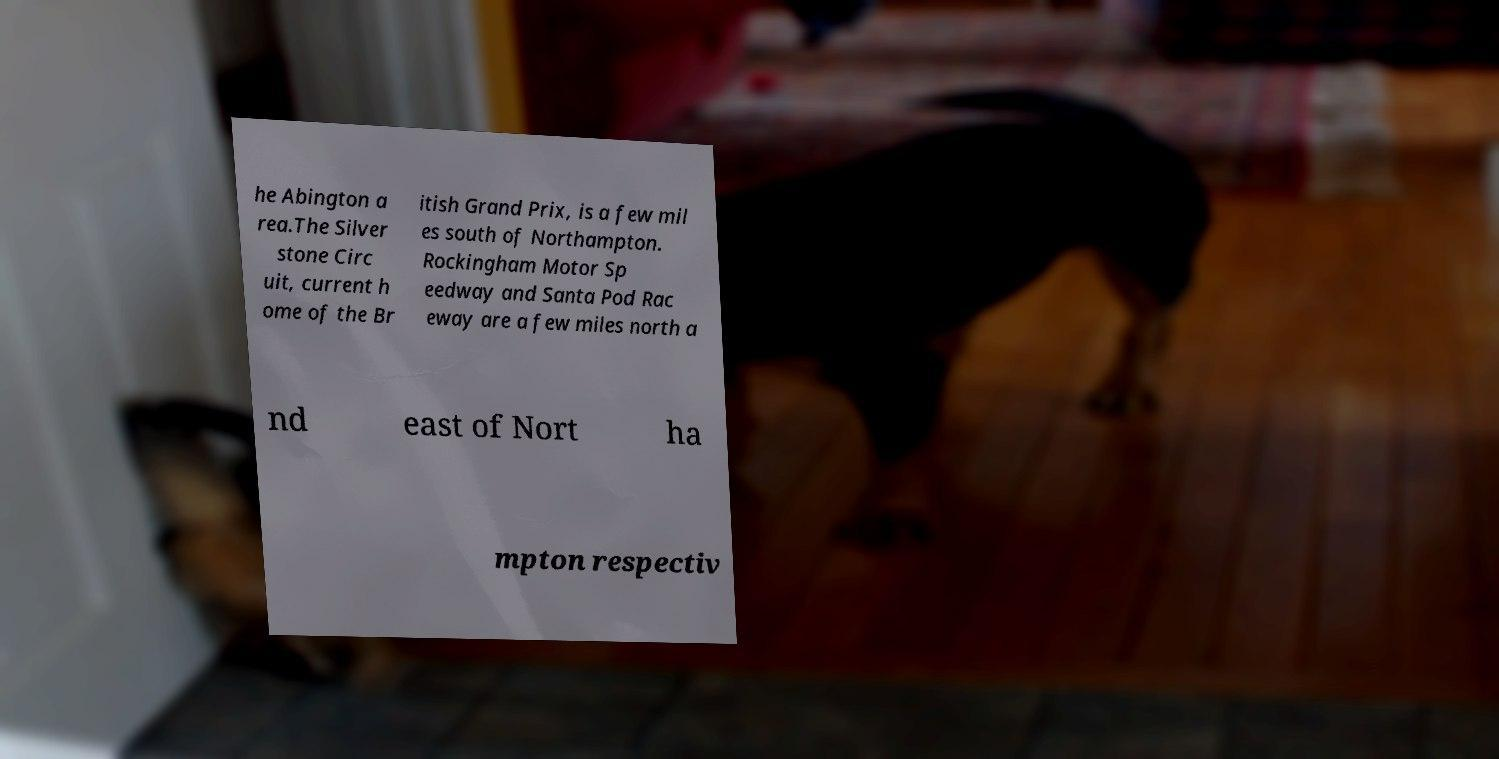Please read and relay the text visible in this image. What does it say? he Abington a rea.The Silver stone Circ uit, current h ome of the Br itish Grand Prix, is a few mil es south of Northampton. Rockingham Motor Sp eedway and Santa Pod Rac eway are a few miles north a nd east of Nort ha mpton respectiv 